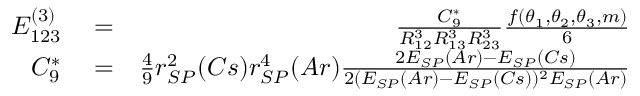Convert formula to latex. <formula><loc_0><loc_0><loc_500><loc_500>\begin{array} { r l r } { E _ { 1 2 3 } ^ { ( 3 ) } } & = } & { \frac { C _ { 9 } ^ { * } } { R _ { 1 2 } ^ { 3 } R _ { 1 3 } ^ { 3 } R _ { 2 3 } ^ { 3 } } \frac { f ( \theta _ { 1 } , \theta _ { 2 } , \theta _ { 3 } , m ) } { 6 } } \\ { C _ { 9 } ^ { * } } & = } & { \frac { 4 } { 9 } r _ { S P } ^ { 2 } ( C s ) r _ { S P } ^ { 4 } ( A r ) \frac { 2 E _ { S P } ( A r ) - E _ { S P } ( C s ) } { 2 ( E _ { S P } ( A r ) - E _ { S P } ( C s ) ) ^ { 2 } E _ { S P } ( A r ) } } \end{array}</formula> 